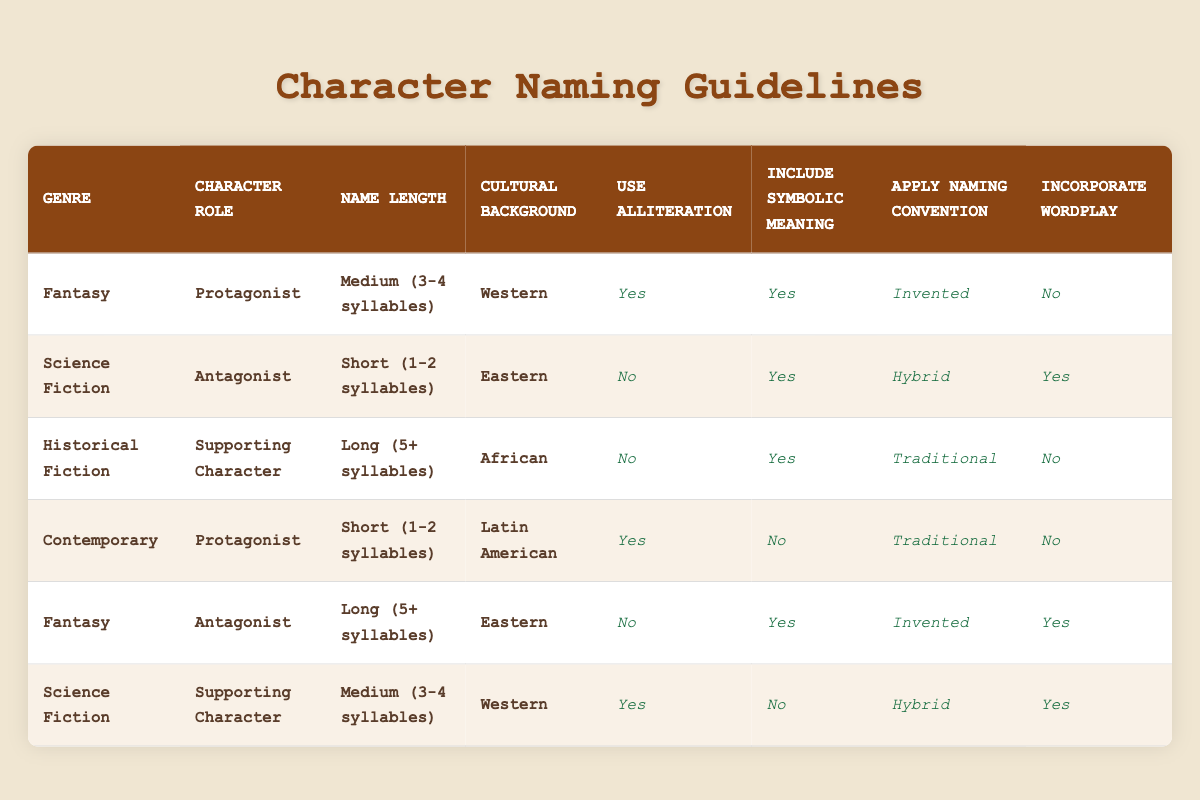What is the character role for a protagonist in the fantasy genre? The table indicates that for a 'Fantasy' genre focus on a 'Protagonist', the named role in the corresponding row is 'Protagonist' itself.
Answer: Protagonist Do any supporting characters in the historical fiction genre have a long name of 5 or more syllables? The table shows that the only entry for 'Historical Fiction' with a 'Supporting Character' and a 'Long (5+ syllables)' name has a 'Yes' for including symbolic meaning. Thus, it shows the presence of supporting characters that fit this description.
Answer: Yes How many different applications of naming conventions appear in Science Fiction? In the Science Fiction category, there are two naming conventions present in the rows: one is 'Hybrid' for the antagonist with a short name, and one is 'Hybrid' for the supporting character with a medium name, resulting in two occurrences.
Answer: 2 Is alliteration used for any short-named protagonists in the contemporary category? The table indicates that for the 'Contemporary' genre with a 'Protagonist' having a 'Short (1-2 syllables)' name, the row shows that alliteration is applied (‘Yes’).
Answer: Yes For antagonists in the fantasy genre, do they all include symbolic meaning? There are two rows for 'Fantasy' with the role of 'Antagonist'—one for a long name has yes for including symbolic meaning, and the other concerning short names has no—they don't uniformly include it across all entries.
Answer: No What unique naming convention is applied to protagonist names in the Western cultural background? Referring to the 'Fantasy' genre, the unique naming convention for a 'Protagonist' with a 'Medium (3-4 syllables)' name of 'Western' origin is 'Invented' as per the corresponding row.
Answer: Invented Which character roles in the Eastern cultural background use wordplay? The only entry under Eastern cultural backgrounds that utilizes wordplay is the 'Science Fiction' Antagonist with a short name who has 'Yes' for incorporating wordplay.
Answer: Antagonist What is the average length of names for supporting characters across all genres mentioned? Analyzing the entries: Historical fiction has 'Long (5+ syllables)', Sci-Fi has 'Medium (3-4 syllables)', and Fantasy's supporting character is also 'Medium', totaling different types. Therefore, it averages out to 'Medium'.
Answer: Medium 